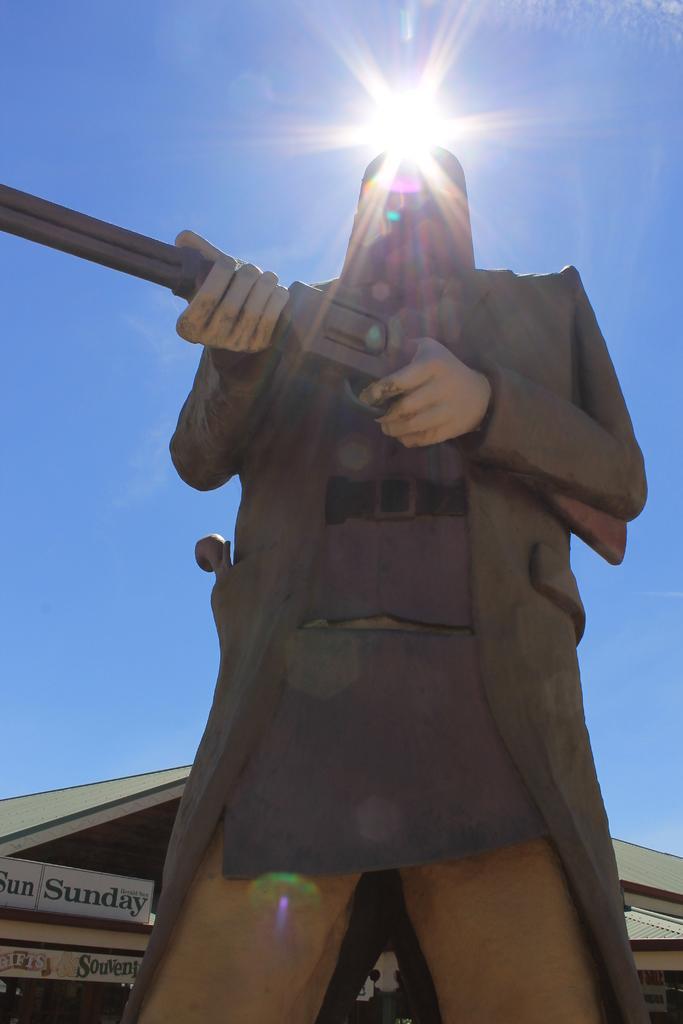Can you describe this image briefly? This is a statue of a person holding a gun. In the background there is a building with boards and sky with sun. 